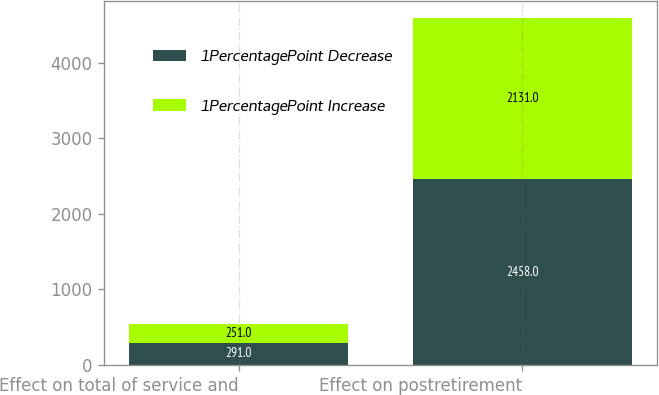Convert chart to OTSL. <chart><loc_0><loc_0><loc_500><loc_500><stacked_bar_chart><ecel><fcel>Effect on total of service and<fcel>Effect on postretirement<nl><fcel>1PercentagePoint Decrease<fcel>291<fcel>2458<nl><fcel>1PercentagePoint Increase<fcel>251<fcel>2131<nl></chart> 